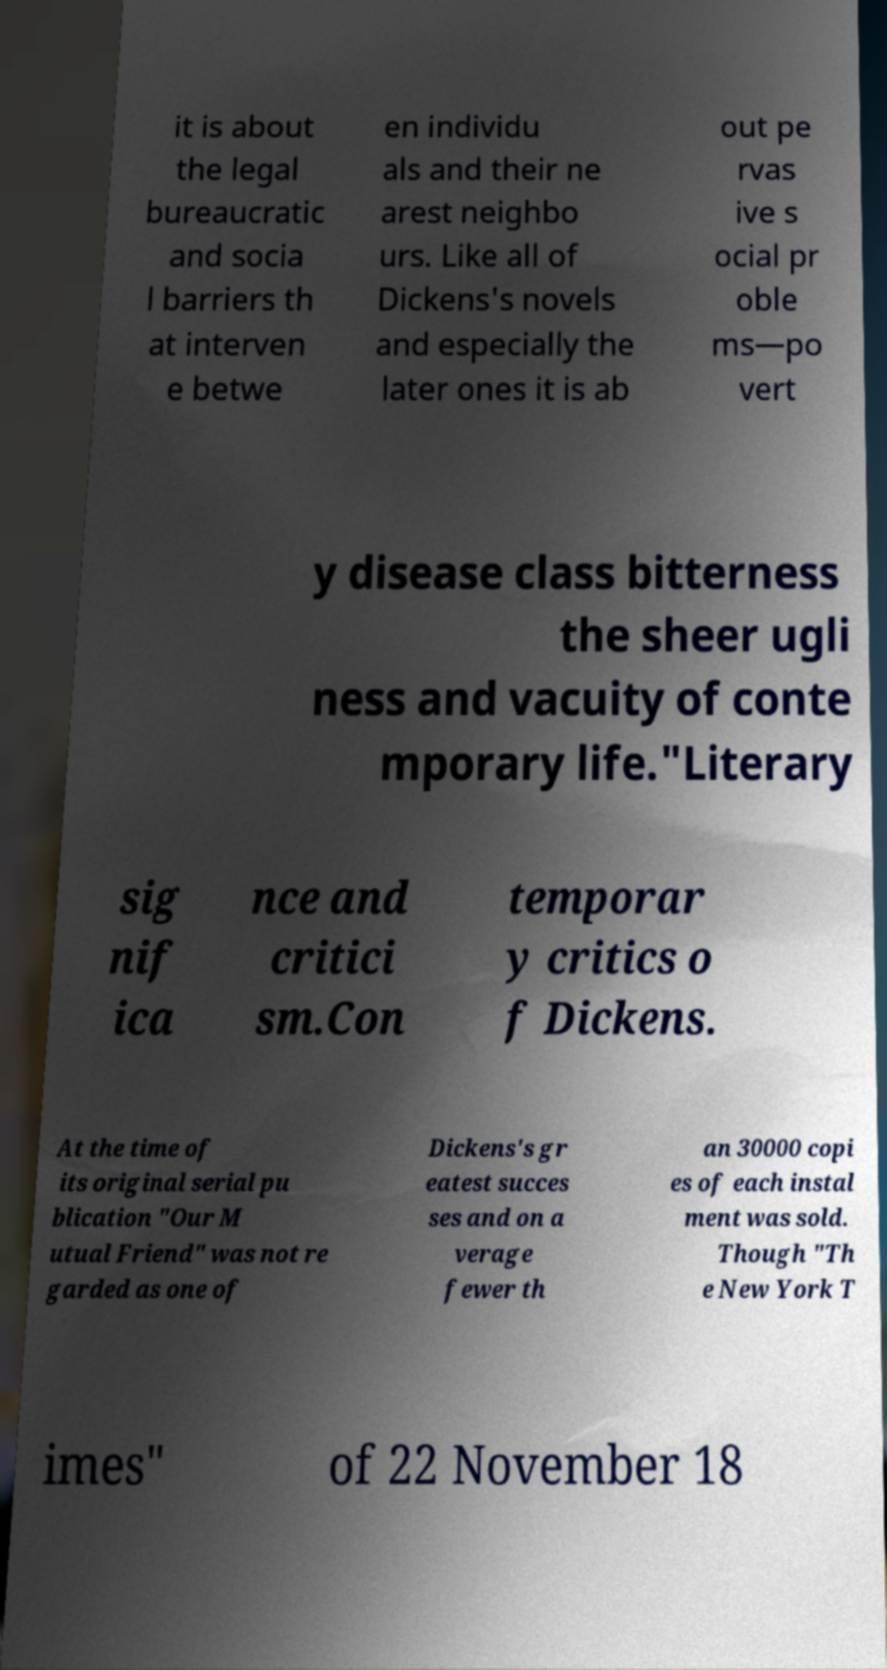Please identify and transcribe the text found in this image. it is about the legal bureaucratic and socia l barriers th at interven e betwe en individu als and their ne arest neighbo urs. Like all of Dickens's novels and especially the later ones it is ab out pe rvas ive s ocial pr oble ms—po vert y disease class bitterness the sheer ugli ness and vacuity of conte mporary life."Literary sig nif ica nce and critici sm.Con temporar y critics o f Dickens. At the time of its original serial pu blication "Our M utual Friend" was not re garded as one of Dickens's gr eatest succes ses and on a verage fewer th an 30000 copi es of each instal ment was sold. Though "Th e New York T imes" of 22 November 18 